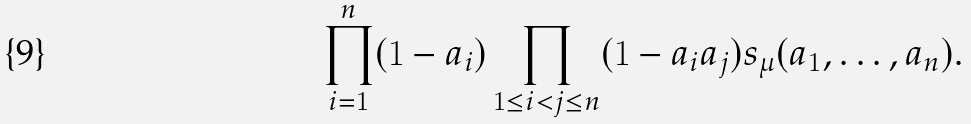Convert formula to latex. <formula><loc_0><loc_0><loc_500><loc_500>\prod _ { i = 1 } ^ { n } ( 1 - a _ { i } ) \prod _ { 1 \leq i < j \leq n } ( 1 - a _ { i } a _ { j } ) s _ { \mu } ( a _ { 1 } , \dots , a _ { n } ) .</formula> 